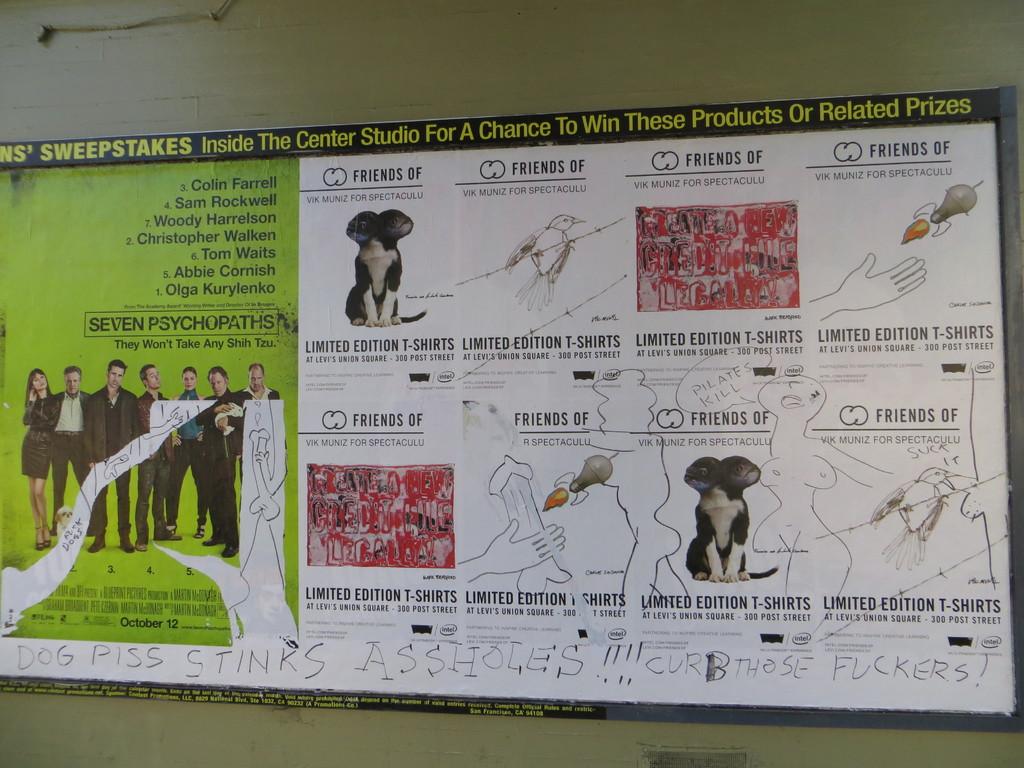Can i win a dog from this?
Provide a succinct answer. No. What is the date on the seven psychopaths poster?
Provide a short and direct response. October 12. 